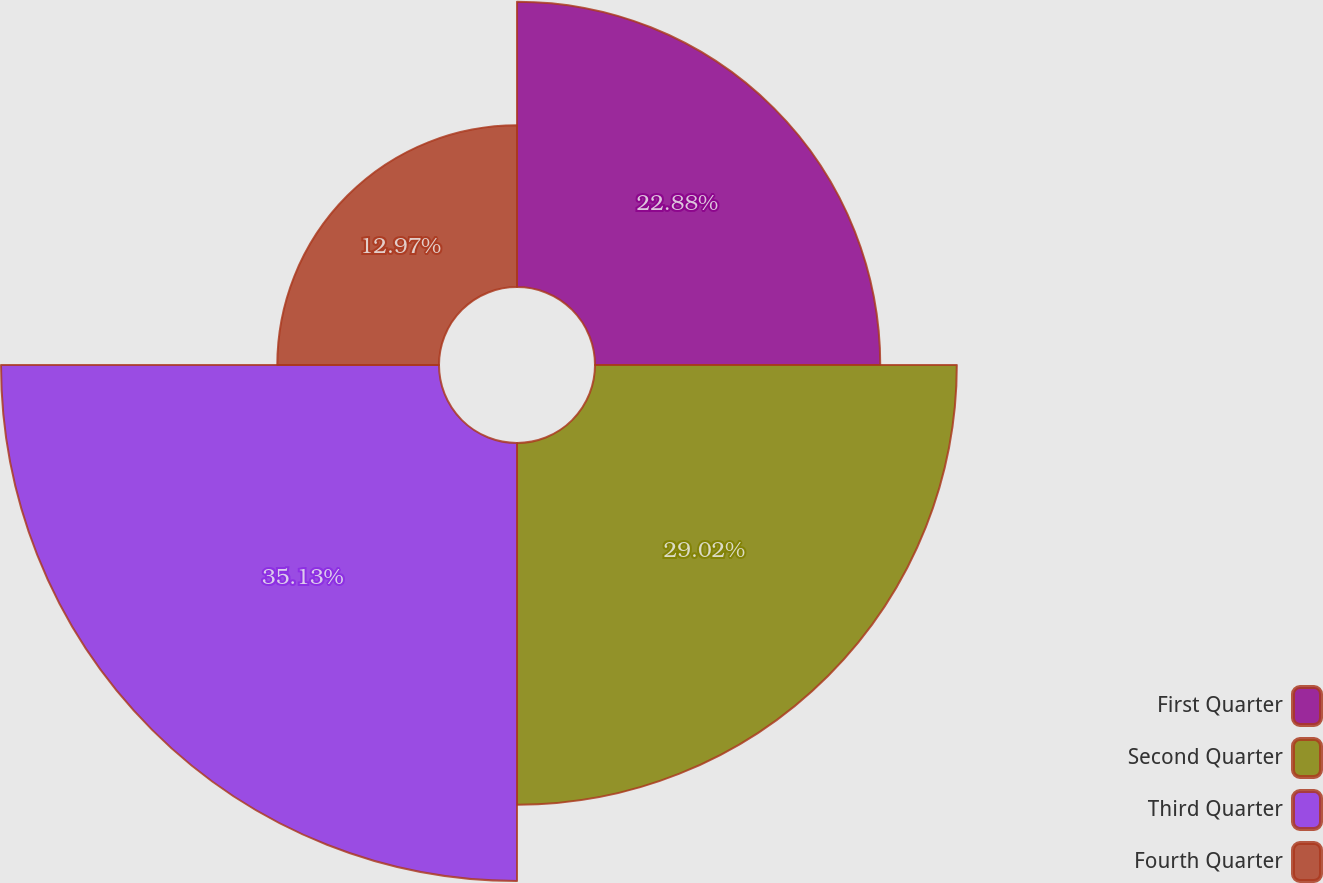<chart> <loc_0><loc_0><loc_500><loc_500><pie_chart><fcel>First Quarter<fcel>Second Quarter<fcel>Third Quarter<fcel>Fourth Quarter<nl><fcel>22.88%<fcel>29.02%<fcel>35.13%<fcel>12.97%<nl></chart> 